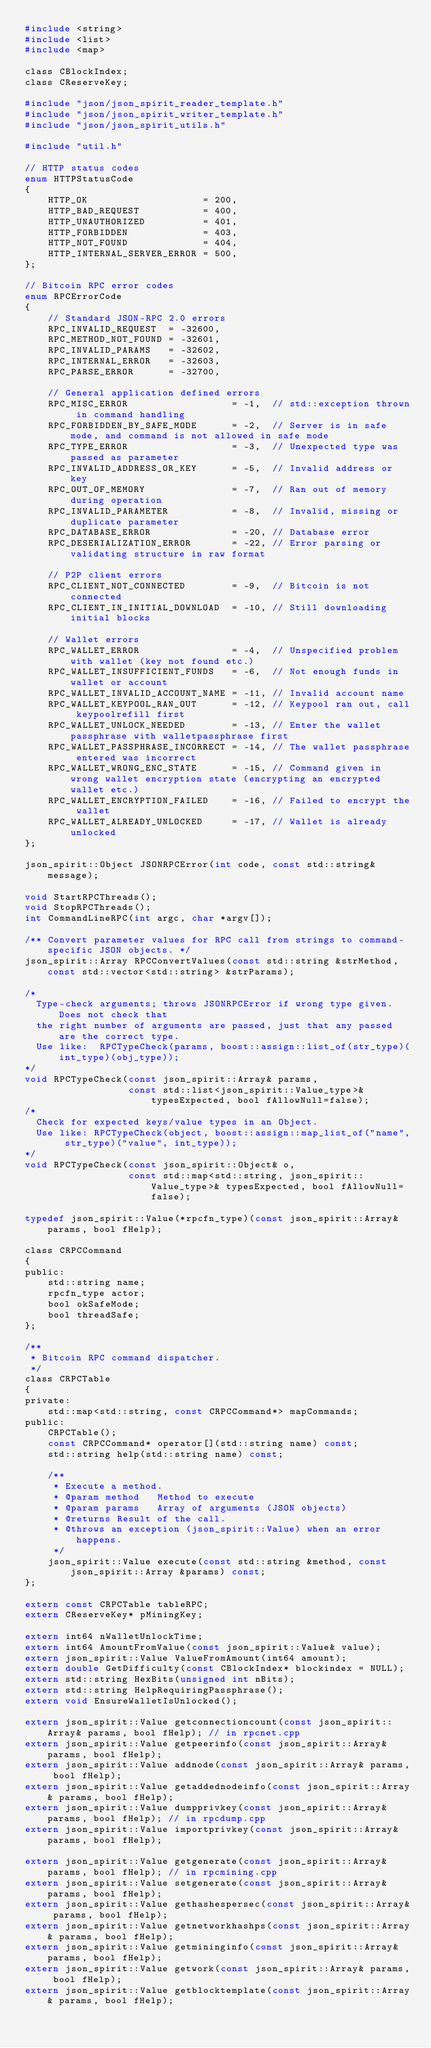<code> <loc_0><loc_0><loc_500><loc_500><_C_>#include <string>
#include <list>
#include <map>

class CBlockIndex;
class CReserveKey;

#include "json/json_spirit_reader_template.h"
#include "json/json_spirit_writer_template.h"
#include "json/json_spirit_utils.h"

#include "util.h"

// HTTP status codes
enum HTTPStatusCode
{
    HTTP_OK                    = 200,
    HTTP_BAD_REQUEST           = 400,
    HTTP_UNAUTHORIZED          = 401,
    HTTP_FORBIDDEN             = 403,
    HTTP_NOT_FOUND             = 404,
    HTTP_INTERNAL_SERVER_ERROR = 500,
};

// Bitcoin RPC error codes
enum RPCErrorCode
{
    // Standard JSON-RPC 2.0 errors
    RPC_INVALID_REQUEST  = -32600,
    RPC_METHOD_NOT_FOUND = -32601,
    RPC_INVALID_PARAMS   = -32602,
    RPC_INTERNAL_ERROR   = -32603,
    RPC_PARSE_ERROR      = -32700,

    // General application defined errors
    RPC_MISC_ERROR                  = -1,  // std::exception thrown in command handling
    RPC_FORBIDDEN_BY_SAFE_MODE      = -2,  // Server is in safe mode, and command is not allowed in safe mode
    RPC_TYPE_ERROR                  = -3,  // Unexpected type was passed as parameter
    RPC_INVALID_ADDRESS_OR_KEY      = -5,  // Invalid address or key
    RPC_OUT_OF_MEMORY               = -7,  // Ran out of memory during operation
    RPC_INVALID_PARAMETER           = -8,  // Invalid, missing or duplicate parameter
    RPC_DATABASE_ERROR              = -20, // Database error
    RPC_DESERIALIZATION_ERROR       = -22, // Error parsing or validating structure in raw format

    // P2P client errors
    RPC_CLIENT_NOT_CONNECTED        = -9,  // Bitcoin is not connected
    RPC_CLIENT_IN_INITIAL_DOWNLOAD  = -10, // Still downloading initial blocks

    // Wallet errors
    RPC_WALLET_ERROR                = -4,  // Unspecified problem with wallet (key not found etc.)
    RPC_WALLET_INSUFFICIENT_FUNDS   = -6,  // Not enough funds in wallet or account
    RPC_WALLET_INVALID_ACCOUNT_NAME = -11, // Invalid account name
    RPC_WALLET_KEYPOOL_RAN_OUT      = -12, // Keypool ran out, call keypoolrefill first
    RPC_WALLET_UNLOCK_NEEDED        = -13, // Enter the wallet passphrase with walletpassphrase first
    RPC_WALLET_PASSPHRASE_INCORRECT = -14, // The wallet passphrase entered was incorrect
    RPC_WALLET_WRONG_ENC_STATE      = -15, // Command given in wrong wallet encryption state (encrypting an encrypted wallet etc.)
    RPC_WALLET_ENCRYPTION_FAILED    = -16, // Failed to encrypt the wallet
    RPC_WALLET_ALREADY_UNLOCKED     = -17, // Wallet is already unlocked
};

json_spirit::Object JSONRPCError(int code, const std::string& message);

void StartRPCThreads();
void StopRPCThreads();
int CommandLineRPC(int argc, char *argv[]);

/** Convert parameter values for RPC call from strings to command-specific JSON objects. */
json_spirit::Array RPCConvertValues(const std::string &strMethod, const std::vector<std::string> &strParams);

/*
  Type-check arguments; throws JSONRPCError if wrong type given. Does not check that
  the right number of arguments are passed, just that any passed are the correct type.
  Use like:  RPCTypeCheck(params, boost::assign::list_of(str_type)(int_type)(obj_type));
*/
void RPCTypeCheck(const json_spirit::Array& params,
                  const std::list<json_spirit::Value_type>& typesExpected, bool fAllowNull=false);
/*
  Check for expected keys/value types in an Object.
  Use like: RPCTypeCheck(object, boost::assign::map_list_of("name", str_type)("value", int_type));
*/
void RPCTypeCheck(const json_spirit::Object& o,
                  const std::map<std::string, json_spirit::Value_type>& typesExpected, bool fAllowNull=false);

typedef json_spirit::Value(*rpcfn_type)(const json_spirit::Array& params, bool fHelp);

class CRPCCommand
{
public:
    std::string name;
    rpcfn_type actor;
    bool okSafeMode;
    bool threadSafe;
};

/**
 * Bitcoin RPC command dispatcher.
 */
class CRPCTable
{
private:
    std::map<std::string, const CRPCCommand*> mapCommands;
public:
    CRPCTable();
    const CRPCCommand* operator[](std::string name) const;
    std::string help(std::string name) const;

    /**
     * Execute a method.
     * @param method   Method to execute
     * @param params   Array of arguments (JSON objects)
     * @returns Result of the call.
     * @throws an exception (json_spirit::Value) when an error happens.
     */
    json_spirit::Value execute(const std::string &method, const json_spirit::Array &params) const;
};

extern const CRPCTable tableRPC;
extern CReserveKey* pMiningKey;

extern int64 nWalletUnlockTime;
extern int64 AmountFromValue(const json_spirit::Value& value);
extern json_spirit::Value ValueFromAmount(int64 amount);
extern double GetDifficulty(const CBlockIndex* blockindex = NULL);
extern std::string HexBits(unsigned int nBits);
extern std::string HelpRequiringPassphrase();
extern void EnsureWalletIsUnlocked();

extern json_spirit::Value getconnectioncount(const json_spirit::Array& params, bool fHelp); // in rpcnet.cpp
extern json_spirit::Value getpeerinfo(const json_spirit::Array& params, bool fHelp);
extern json_spirit::Value addnode(const json_spirit::Array& params, bool fHelp);
extern json_spirit::Value getaddednodeinfo(const json_spirit::Array& params, bool fHelp);
extern json_spirit::Value dumpprivkey(const json_spirit::Array& params, bool fHelp); // in rpcdump.cpp
extern json_spirit::Value importprivkey(const json_spirit::Array& params, bool fHelp);

extern json_spirit::Value getgenerate(const json_spirit::Array& params, bool fHelp); // in rpcmining.cpp
extern json_spirit::Value setgenerate(const json_spirit::Array& params, bool fHelp);
extern json_spirit::Value gethashespersec(const json_spirit::Array& params, bool fHelp);
extern json_spirit::Value getnetworkhashps(const json_spirit::Array& params, bool fHelp);
extern json_spirit::Value getmininginfo(const json_spirit::Array& params, bool fHelp);
extern json_spirit::Value getwork(const json_spirit::Array& params, bool fHelp);
extern json_spirit::Value getblocktemplate(const json_spirit::Array& params, bool fHelp);</code> 